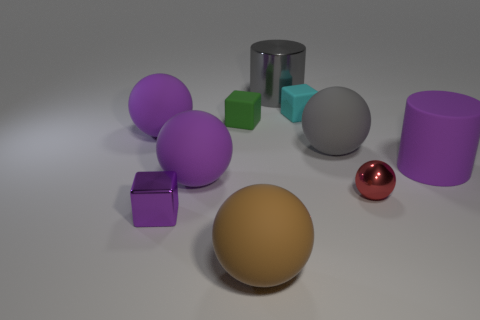Subtract all red balls. How many balls are left? 4 Subtract all tiny balls. How many balls are left? 4 Subtract 2 balls. How many balls are left? 3 Subtract all yellow spheres. Subtract all blue cylinders. How many spheres are left? 5 Subtract all blocks. How many objects are left? 7 Add 9 small cyan cubes. How many small cyan cubes exist? 10 Subtract 0 brown cubes. How many objects are left? 10 Subtract all green rubber objects. Subtract all big purple objects. How many objects are left? 6 Add 1 cylinders. How many cylinders are left? 3 